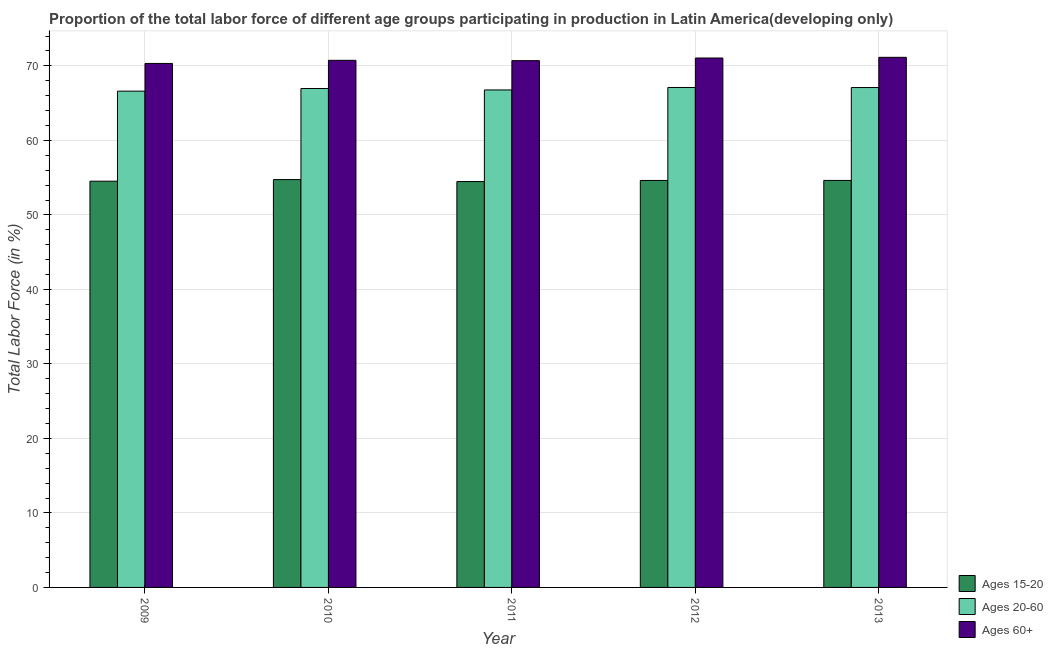How many different coloured bars are there?
Your response must be concise. 3. How many groups of bars are there?
Your answer should be compact. 5. Are the number of bars per tick equal to the number of legend labels?
Your answer should be very brief. Yes. What is the percentage of labor force within the age group 20-60 in 2010?
Your response must be concise. 66.96. Across all years, what is the maximum percentage of labor force above age 60?
Make the answer very short. 71.15. Across all years, what is the minimum percentage of labor force above age 60?
Offer a very short reply. 70.33. In which year was the percentage of labor force within the age group 15-20 minimum?
Your answer should be very brief. 2011. What is the total percentage of labor force within the age group 20-60 in the graph?
Give a very brief answer. 334.54. What is the difference between the percentage of labor force above age 60 in 2010 and that in 2011?
Ensure brevity in your answer.  0.04. What is the difference between the percentage of labor force above age 60 in 2013 and the percentage of labor force within the age group 15-20 in 2012?
Provide a succinct answer. 0.09. What is the average percentage of labor force within the age group 20-60 per year?
Your response must be concise. 66.91. In how many years, is the percentage of labor force above age 60 greater than 4 %?
Offer a very short reply. 5. What is the ratio of the percentage of labor force above age 60 in 2012 to that in 2013?
Offer a very short reply. 1. What is the difference between the highest and the second highest percentage of labor force above age 60?
Offer a terse response. 0.09. What is the difference between the highest and the lowest percentage of labor force within the age group 20-60?
Ensure brevity in your answer.  0.49. In how many years, is the percentage of labor force within the age group 20-60 greater than the average percentage of labor force within the age group 20-60 taken over all years?
Your response must be concise. 3. Is the sum of the percentage of labor force within the age group 20-60 in 2011 and 2013 greater than the maximum percentage of labor force above age 60 across all years?
Offer a terse response. Yes. What does the 3rd bar from the left in 2009 represents?
Provide a short and direct response. Ages 60+. What does the 1st bar from the right in 2011 represents?
Keep it short and to the point. Ages 60+. How many bars are there?
Your answer should be very brief. 15. Are all the bars in the graph horizontal?
Offer a terse response. No. Are the values on the major ticks of Y-axis written in scientific E-notation?
Your answer should be compact. No. Does the graph contain any zero values?
Provide a short and direct response. No. Does the graph contain grids?
Your answer should be compact. Yes. What is the title of the graph?
Make the answer very short. Proportion of the total labor force of different age groups participating in production in Latin America(developing only). What is the label or title of the X-axis?
Offer a terse response. Year. What is the Total Labor Force (in %) of Ages 15-20 in 2009?
Provide a short and direct response. 54.53. What is the Total Labor Force (in %) in Ages 20-60 in 2009?
Your answer should be compact. 66.61. What is the Total Labor Force (in %) in Ages 60+ in 2009?
Provide a succinct answer. 70.33. What is the Total Labor Force (in %) in Ages 15-20 in 2010?
Give a very brief answer. 54.74. What is the Total Labor Force (in %) of Ages 20-60 in 2010?
Give a very brief answer. 66.96. What is the Total Labor Force (in %) in Ages 60+ in 2010?
Offer a very short reply. 70.75. What is the Total Labor Force (in %) in Ages 15-20 in 2011?
Your answer should be very brief. 54.48. What is the Total Labor Force (in %) of Ages 20-60 in 2011?
Keep it short and to the point. 66.77. What is the Total Labor Force (in %) of Ages 60+ in 2011?
Your answer should be compact. 70.7. What is the Total Labor Force (in %) of Ages 15-20 in 2012?
Give a very brief answer. 54.63. What is the Total Labor Force (in %) in Ages 20-60 in 2012?
Provide a succinct answer. 67.1. What is the Total Labor Force (in %) of Ages 60+ in 2012?
Your answer should be very brief. 71.06. What is the Total Labor Force (in %) of Ages 15-20 in 2013?
Your response must be concise. 54.63. What is the Total Labor Force (in %) of Ages 20-60 in 2013?
Keep it short and to the point. 67.1. What is the Total Labor Force (in %) in Ages 60+ in 2013?
Keep it short and to the point. 71.15. Across all years, what is the maximum Total Labor Force (in %) in Ages 15-20?
Provide a short and direct response. 54.74. Across all years, what is the maximum Total Labor Force (in %) in Ages 20-60?
Ensure brevity in your answer.  67.1. Across all years, what is the maximum Total Labor Force (in %) of Ages 60+?
Your answer should be very brief. 71.15. Across all years, what is the minimum Total Labor Force (in %) in Ages 15-20?
Provide a short and direct response. 54.48. Across all years, what is the minimum Total Labor Force (in %) of Ages 20-60?
Your answer should be compact. 66.61. Across all years, what is the minimum Total Labor Force (in %) of Ages 60+?
Offer a very short reply. 70.33. What is the total Total Labor Force (in %) in Ages 15-20 in the graph?
Provide a succinct answer. 272.99. What is the total Total Labor Force (in %) in Ages 20-60 in the graph?
Give a very brief answer. 334.54. What is the total Total Labor Force (in %) in Ages 60+ in the graph?
Provide a succinct answer. 353.99. What is the difference between the Total Labor Force (in %) of Ages 15-20 in 2009 and that in 2010?
Provide a short and direct response. -0.21. What is the difference between the Total Labor Force (in %) in Ages 20-60 in 2009 and that in 2010?
Your answer should be compact. -0.36. What is the difference between the Total Labor Force (in %) in Ages 60+ in 2009 and that in 2010?
Make the answer very short. -0.42. What is the difference between the Total Labor Force (in %) of Ages 15-20 in 2009 and that in 2011?
Provide a succinct answer. 0.05. What is the difference between the Total Labor Force (in %) of Ages 20-60 in 2009 and that in 2011?
Offer a very short reply. -0.16. What is the difference between the Total Labor Force (in %) of Ages 60+ in 2009 and that in 2011?
Your answer should be compact. -0.38. What is the difference between the Total Labor Force (in %) of Ages 15-20 in 2009 and that in 2012?
Your answer should be very brief. -0.1. What is the difference between the Total Labor Force (in %) in Ages 20-60 in 2009 and that in 2012?
Offer a terse response. -0.49. What is the difference between the Total Labor Force (in %) of Ages 60+ in 2009 and that in 2012?
Keep it short and to the point. -0.73. What is the difference between the Total Labor Force (in %) of Ages 15-20 in 2009 and that in 2013?
Your answer should be very brief. -0.1. What is the difference between the Total Labor Force (in %) of Ages 20-60 in 2009 and that in 2013?
Keep it short and to the point. -0.49. What is the difference between the Total Labor Force (in %) in Ages 60+ in 2009 and that in 2013?
Ensure brevity in your answer.  -0.82. What is the difference between the Total Labor Force (in %) of Ages 15-20 in 2010 and that in 2011?
Ensure brevity in your answer.  0.26. What is the difference between the Total Labor Force (in %) in Ages 20-60 in 2010 and that in 2011?
Your answer should be compact. 0.19. What is the difference between the Total Labor Force (in %) in Ages 60+ in 2010 and that in 2011?
Make the answer very short. 0.04. What is the difference between the Total Labor Force (in %) of Ages 15-20 in 2010 and that in 2012?
Make the answer very short. 0.11. What is the difference between the Total Labor Force (in %) of Ages 20-60 in 2010 and that in 2012?
Provide a succinct answer. -0.14. What is the difference between the Total Labor Force (in %) in Ages 60+ in 2010 and that in 2012?
Ensure brevity in your answer.  -0.31. What is the difference between the Total Labor Force (in %) of Ages 15-20 in 2010 and that in 2013?
Give a very brief answer. 0.11. What is the difference between the Total Labor Force (in %) of Ages 20-60 in 2010 and that in 2013?
Your answer should be very brief. -0.13. What is the difference between the Total Labor Force (in %) of Ages 60+ in 2010 and that in 2013?
Your answer should be compact. -0.4. What is the difference between the Total Labor Force (in %) in Ages 15-20 in 2011 and that in 2012?
Offer a very short reply. -0.15. What is the difference between the Total Labor Force (in %) in Ages 20-60 in 2011 and that in 2012?
Give a very brief answer. -0.33. What is the difference between the Total Labor Force (in %) of Ages 60+ in 2011 and that in 2012?
Give a very brief answer. -0.35. What is the difference between the Total Labor Force (in %) in Ages 15-20 in 2011 and that in 2013?
Your answer should be very brief. -0.15. What is the difference between the Total Labor Force (in %) of Ages 20-60 in 2011 and that in 2013?
Give a very brief answer. -0.32. What is the difference between the Total Labor Force (in %) in Ages 60+ in 2011 and that in 2013?
Your answer should be very brief. -0.44. What is the difference between the Total Labor Force (in %) of Ages 15-20 in 2012 and that in 2013?
Give a very brief answer. -0. What is the difference between the Total Labor Force (in %) of Ages 20-60 in 2012 and that in 2013?
Ensure brevity in your answer.  0.01. What is the difference between the Total Labor Force (in %) in Ages 60+ in 2012 and that in 2013?
Your answer should be very brief. -0.09. What is the difference between the Total Labor Force (in %) of Ages 15-20 in 2009 and the Total Labor Force (in %) of Ages 20-60 in 2010?
Ensure brevity in your answer.  -12.44. What is the difference between the Total Labor Force (in %) in Ages 15-20 in 2009 and the Total Labor Force (in %) in Ages 60+ in 2010?
Keep it short and to the point. -16.22. What is the difference between the Total Labor Force (in %) of Ages 20-60 in 2009 and the Total Labor Force (in %) of Ages 60+ in 2010?
Offer a terse response. -4.14. What is the difference between the Total Labor Force (in %) of Ages 15-20 in 2009 and the Total Labor Force (in %) of Ages 20-60 in 2011?
Your answer should be very brief. -12.25. What is the difference between the Total Labor Force (in %) of Ages 15-20 in 2009 and the Total Labor Force (in %) of Ages 60+ in 2011?
Your response must be concise. -16.18. What is the difference between the Total Labor Force (in %) in Ages 20-60 in 2009 and the Total Labor Force (in %) in Ages 60+ in 2011?
Give a very brief answer. -4.09. What is the difference between the Total Labor Force (in %) in Ages 15-20 in 2009 and the Total Labor Force (in %) in Ages 20-60 in 2012?
Provide a succinct answer. -12.58. What is the difference between the Total Labor Force (in %) of Ages 15-20 in 2009 and the Total Labor Force (in %) of Ages 60+ in 2012?
Give a very brief answer. -16.53. What is the difference between the Total Labor Force (in %) in Ages 20-60 in 2009 and the Total Labor Force (in %) in Ages 60+ in 2012?
Provide a short and direct response. -4.45. What is the difference between the Total Labor Force (in %) of Ages 15-20 in 2009 and the Total Labor Force (in %) of Ages 20-60 in 2013?
Provide a short and direct response. -12.57. What is the difference between the Total Labor Force (in %) in Ages 15-20 in 2009 and the Total Labor Force (in %) in Ages 60+ in 2013?
Provide a short and direct response. -16.62. What is the difference between the Total Labor Force (in %) of Ages 20-60 in 2009 and the Total Labor Force (in %) of Ages 60+ in 2013?
Make the answer very short. -4.54. What is the difference between the Total Labor Force (in %) in Ages 15-20 in 2010 and the Total Labor Force (in %) in Ages 20-60 in 2011?
Provide a short and direct response. -12.03. What is the difference between the Total Labor Force (in %) of Ages 15-20 in 2010 and the Total Labor Force (in %) of Ages 60+ in 2011?
Offer a terse response. -15.97. What is the difference between the Total Labor Force (in %) in Ages 20-60 in 2010 and the Total Labor Force (in %) in Ages 60+ in 2011?
Ensure brevity in your answer.  -3.74. What is the difference between the Total Labor Force (in %) in Ages 15-20 in 2010 and the Total Labor Force (in %) in Ages 20-60 in 2012?
Your answer should be very brief. -12.36. What is the difference between the Total Labor Force (in %) of Ages 15-20 in 2010 and the Total Labor Force (in %) of Ages 60+ in 2012?
Your response must be concise. -16.32. What is the difference between the Total Labor Force (in %) of Ages 20-60 in 2010 and the Total Labor Force (in %) of Ages 60+ in 2012?
Offer a very short reply. -4.09. What is the difference between the Total Labor Force (in %) of Ages 15-20 in 2010 and the Total Labor Force (in %) of Ages 20-60 in 2013?
Provide a succinct answer. -12.36. What is the difference between the Total Labor Force (in %) in Ages 15-20 in 2010 and the Total Labor Force (in %) in Ages 60+ in 2013?
Your answer should be compact. -16.41. What is the difference between the Total Labor Force (in %) of Ages 20-60 in 2010 and the Total Labor Force (in %) of Ages 60+ in 2013?
Provide a short and direct response. -4.18. What is the difference between the Total Labor Force (in %) of Ages 15-20 in 2011 and the Total Labor Force (in %) of Ages 20-60 in 2012?
Keep it short and to the point. -12.63. What is the difference between the Total Labor Force (in %) in Ages 15-20 in 2011 and the Total Labor Force (in %) in Ages 60+ in 2012?
Your answer should be very brief. -16.58. What is the difference between the Total Labor Force (in %) in Ages 20-60 in 2011 and the Total Labor Force (in %) in Ages 60+ in 2012?
Make the answer very short. -4.29. What is the difference between the Total Labor Force (in %) in Ages 15-20 in 2011 and the Total Labor Force (in %) in Ages 20-60 in 2013?
Offer a terse response. -12.62. What is the difference between the Total Labor Force (in %) of Ages 15-20 in 2011 and the Total Labor Force (in %) of Ages 60+ in 2013?
Provide a succinct answer. -16.67. What is the difference between the Total Labor Force (in %) in Ages 20-60 in 2011 and the Total Labor Force (in %) in Ages 60+ in 2013?
Provide a short and direct response. -4.38. What is the difference between the Total Labor Force (in %) of Ages 15-20 in 2012 and the Total Labor Force (in %) of Ages 20-60 in 2013?
Provide a short and direct response. -12.47. What is the difference between the Total Labor Force (in %) of Ages 15-20 in 2012 and the Total Labor Force (in %) of Ages 60+ in 2013?
Provide a short and direct response. -16.52. What is the difference between the Total Labor Force (in %) in Ages 20-60 in 2012 and the Total Labor Force (in %) in Ages 60+ in 2013?
Make the answer very short. -4.05. What is the average Total Labor Force (in %) of Ages 15-20 per year?
Offer a very short reply. 54.6. What is the average Total Labor Force (in %) in Ages 20-60 per year?
Make the answer very short. 66.91. What is the average Total Labor Force (in %) in Ages 60+ per year?
Make the answer very short. 70.8. In the year 2009, what is the difference between the Total Labor Force (in %) in Ages 15-20 and Total Labor Force (in %) in Ages 20-60?
Your response must be concise. -12.08. In the year 2009, what is the difference between the Total Labor Force (in %) of Ages 15-20 and Total Labor Force (in %) of Ages 60+?
Your response must be concise. -15.8. In the year 2009, what is the difference between the Total Labor Force (in %) of Ages 20-60 and Total Labor Force (in %) of Ages 60+?
Make the answer very short. -3.72. In the year 2010, what is the difference between the Total Labor Force (in %) of Ages 15-20 and Total Labor Force (in %) of Ages 20-60?
Your answer should be very brief. -12.23. In the year 2010, what is the difference between the Total Labor Force (in %) of Ages 15-20 and Total Labor Force (in %) of Ages 60+?
Keep it short and to the point. -16.01. In the year 2010, what is the difference between the Total Labor Force (in %) of Ages 20-60 and Total Labor Force (in %) of Ages 60+?
Offer a very short reply. -3.78. In the year 2011, what is the difference between the Total Labor Force (in %) in Ages 15-20 and Total Labor Force (in %) in Ages 20-60?
Give a very brief answer. -12.3. In the year 2011, what is the difference between the Total Labor Force (in %) of Ages 15-20 and Total Labor Force (in %) of Ages 60+?
Offer a very short reply. -16.23. In the year 2011, what is the difference between the Total Labor Force (in %) of Ages 20-60 and Total Labor Force (in %) of Ages 60+?
Ensure brevity in your answer.  -3.93. In the year 2012, what is the difference between the Total Labor Force (in %) in Ages 15-20 and Total Labor Force (in %) in Ages 20-60?
Your response must be concise. -12.48. In the year 2012, what is the difference between the Total Labor Force (in %) in Ages 15-20 and Total Labor Force (in %) in Ages 60+?
Provide a short and direct response. -16.43. In the year 2012, what is the difference between the Total Labor Force (in %) of Ages 20-60 and Total Labor Force (in %) of Ages 60+?
Give a very brief answer. -3.96. In the year 2013, what is the difference between the Total Labor Force (in %) in Ages 15-20 and Total Labor Force (in %) in Ages 20-60?
Provide a short and direct response. -12.47. In the year 2013, what is the difference between the Total Labor Force (in %) in Ages 15-20 and Total Labor Force (in %) in Ages 60+?
Your answer should be compact. -16.52. In the year 2013, what is the difference between the Total Labor Force (in %) of Ages 20-60 and Total Labor Force (in %) of Ages 60+?
Provide a short and direct response. -4.05. What is the ratio of the Total Labor Force (in %) of Ages 60+ in 2009 to that in 2010?
Offer a terse response. 0.99. What is the ratio of the Total Labor Force (in %) in Ages 15-20 in 2009 to that in 2011?
Provide a short and direct response. 1. What is the ratio of the Total Labor Force (in %) of Ages 20-60 in 2009 to that in 2011?
Provide a short and direct response. 1. What is the ratio of the Total Labor Force (in %) of Ages 60+ in 2009 to that in 2011?
Offer a very short reply. 0.99. What is the ratio of the Total Labor Force (in %) of Ages 60+ in 2009 to that in 2012?
Offer a very short reply. 0.99. What is the ratio of the Total Labor Force (in %) in Ages 15-20 in 2009 to that in 2013?
Ensure brevity in your answer.  1. What is the ratio of the Total Labor Force (in %) in Ages 60+ in 2009 to that in 2013?
Your response must be concise. 0.99. What is the ratio of the Total Labor Force (in %) of Ages 20-60 in 2010 to that in 2011?
Give a very brief answer. 1. What is the ratio of the Total Labor Force (in %) of Ages 60+ in 2010 to that in 2013?
Your response must be concise. 0.99. What is the ratio of the Total Labor Force (in %) in Ages 20-60 in 2011 to that in 2012?
Your answer should be very brief. 1. What is the ratio of the Total Labor Force (in %) in Ages 60+ in 2011 to that in 2012?
Your answer should be very brief. 0.99. What is the ratio of the Total Labor Force (in %) of Ages 15-20 in 2011 to that in 2013?
Offer a terse response. 1. What is the ratio of the Total Labor Force (in %) of Ages 60+ in 2011 to that in 2013?
Your answer should be compact. 0.99. What is the ratio of the Total Labor Force (in %) in Ages 20-60 in 2012 to that in 2013?
Offer a terse response. 1. What is the difference between the highest and the second highest Total Labor Force (in %) of Ages 15-20?
Provide a short and direct response. 0.11. What is the difference between the highest and the second highest Total Labor Force (in %) of Ages 20-60?
Your response must be concise. 0.01. What is the difference between the highest and the second highest Total Labor Force (in %) in Ages 60+?
Keep it short and to the point. 0.09. What is the difference between the highest and the lowest Total Labor Force (in %) of Ages 15-20?
Give a very brief answer. 0.26. What is the difference between the highest and the lowest Total Labor Force (in %) of Ages 20-60?
Offer a terse response. 0.49. What is the difference between the highest and the lowest Total Labor Force (in %) in Ages 60+?
Offer a terse response. 0.82. 